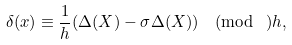Convert formula to latex. <formula><loc_0><loc_0><loc_500><loc_500>\delta ( x ) \equiv \frac { 1 } { h } ( \Delta ( X ) - \sigma \Delta ( X ) ) \pmod { \ } h ,</formula> 